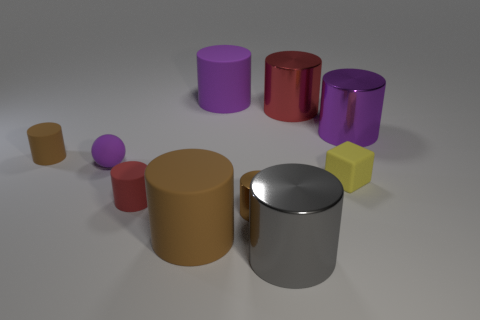There is a brown rubber object that is behind the tiny ball; is its shape the same as the purple metallic object on the right side of the gray metallic thing?
Provide a short and direct response. Yes. Is there a yellow object that has the same material as the yellow cube?
Your response must be concise. No. What number of rubber objects are red cylinders or tiny purple spheres?
Provide a short and direct response. 2. There is a purple rubber object that is right of the red object in front of the big purple metal cylinder; what is its shape?
Keep it short and to the point. Cylinder. Are there fewer tiny red things behind the tiny metal thing than tiny cylinders?
Ensure brevity in your answer.  Yes. The tiny purple rubber object has what shape?
Offer a very short reply. Sphere. How big is the red object that is behind the big purple metal cylinder?
Give a very brief answer. Large. There is a shiny cylinder that is the same size as the sphere; what color is it?
Provide a short and direct response. Brown. Are there any metal things of the same color as the small matte sphere?
Offer a terse response. Yes. Are there fewer big red metal cylinders in front of the small matte ball than purple rubber objects that are left of the purple matte cylinder?
Offer a very short reply. Yes. 